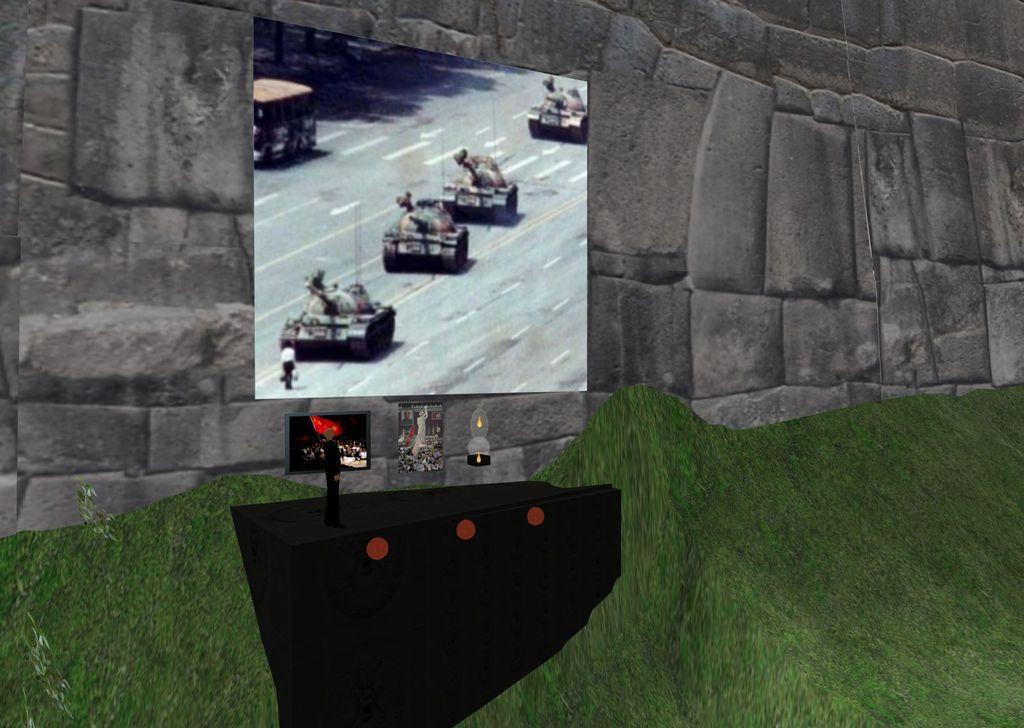How would you summarize this image in a sentence or two? This is a picture of an animation. In the center of the picture there is a screen and remote. At the bottom it is grass. At the top it is well. 